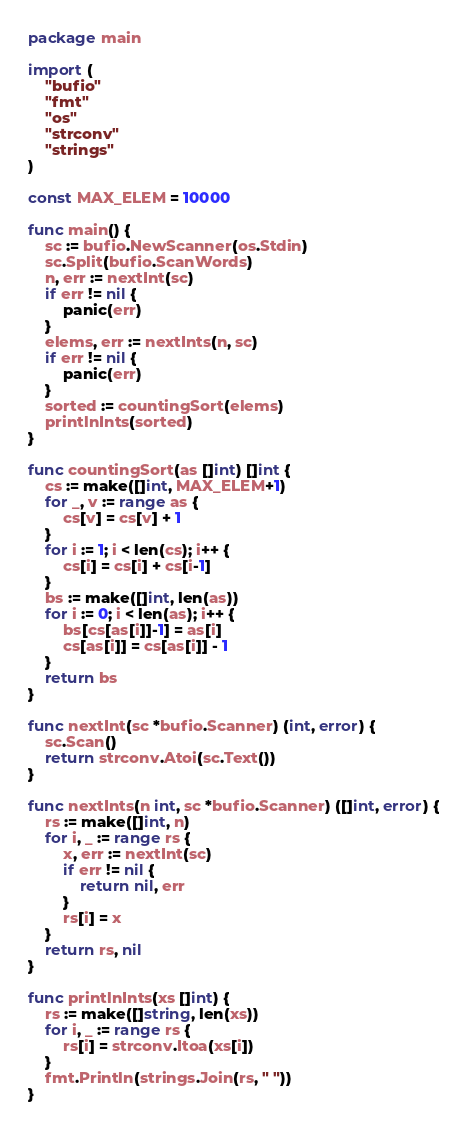<code> <loc_0><loc_0><loc_500><loc_500><_Go_>package main

import (
	"bufio"
	"fmt"
	"os"
	"strconv"
	"strings"
)

const MAX_ELEM = 10000

func main() {
	sc := bufio.NewScanner(os.Stdin)
	sc.Split(bufio.ScanWords)
	n, err := nextInt(sc)
	if err != nil {
		panic(err)
	}
	elems, err := nextInts(n, sc)
	if err != nil {
		panic(err)
	}
	sorted := countingSort(elems)
	printlnInts(sorted)
}

func countingSort(as []int) []int {
	cs := make([]int, MAX_ELEM+1)
	for _, v := range as {
		cs[v] = cs[v] + 1
	}
	for i := 1; i < len(cs); i++ {
		cs[i] = cs[i] + cs[i-1]
	}
	bs := make([]int, len(as))
	for i := 0; i < len(as); i++ {
		bs[cs[as[i]]-1] = as[i]
		cs[as[i]] = cs[as[i]] - 1
	}
	return bs
}

func nextInt(sc *bufio.Scanner) (int, error) {
	sc.Scan()
	return strconv.Atoi(sc.Text())
}

func nextInts(n int, sc *bufio.Scanner) ([]int, error) {
	rs := make([]int, n)
	for i, _ := range rs {
		x, err := nextInt(sc)
		if err != nil {
			return nil, err
		}
		rs[i] = x
	}
	return rs, nil
}

func printlnInts(xs []int) {
	rs := make([]string, len(xs))
	for i, _ := range rs {
		rs[i] = strconv.Itoa(xs[i])
	}
	fmt.Println(strings.Join(rs, " "))
}

</code> 